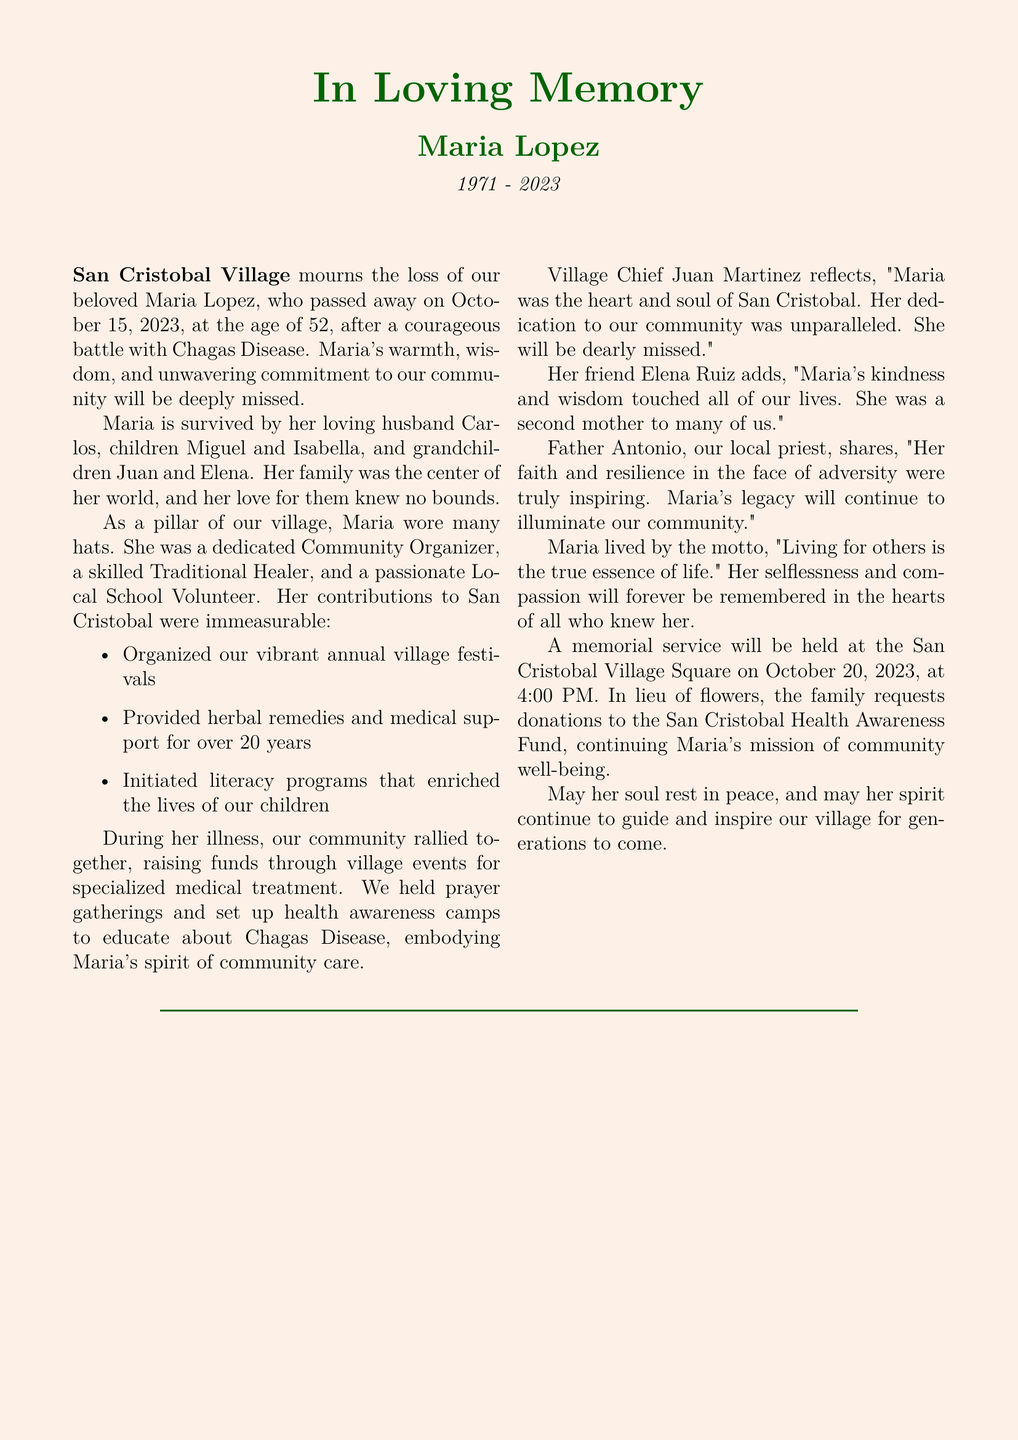What illness did Maria Lopez succumb to? The document specifies that Maria Lopez passed away after a battle with Chagas Disease.
Answer: Chagas Disease What was the age of Maria Lopez when she passed away? The document states that Maria passed away at the age of 52.
Answer: 52 What date did Maria Lopez pass away? The document mentions that Maria Lopez passed away on October 15, 2023.
Answer: October 15, 2023 Who was the Village Chief that reflected on Maria's life? The document indicates that Village Chief Juan Martinez shared reflections about Maria.
Answer: Juan Martinez What was the motto that Maria lived by? The document cites Maria's motto as "Living for others is the true essence of life."
Answer: Living for others is the true essence of life What type of events did the community hold to support Maria during her illness? The document discusses that the community organized village events to raise funds for medical treatment.
Answer: Village events What is one of the contributions Maria made to her community? The document lists that Maria organized vibrant annual village festivals among other contributions.
Answer: Organized our vibrant annual village festivals When is the memorial service for Maria scheduled? The document states that the memorial service will be held on October 20, 2023, at 4:00 PM.
Answer: October 20, 2023, at 4:00 PM What request did Maria's family make in lieu of flowers? The document mentions that the family requests donations to the San Cristobal Health Awareness Fund.
Answer: Donations to the San Cristobal Health Awareness Fund 